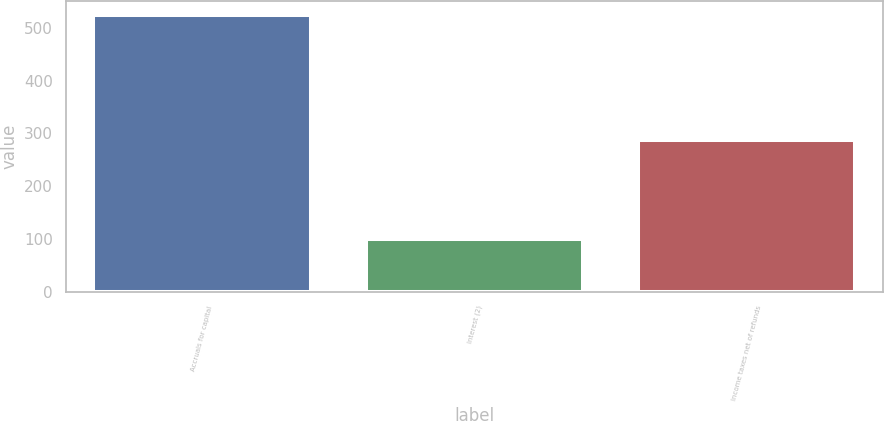<chart> <loc_0><loc_0><loc_500><loc_500><bar_chart><fcel>Accruals for capital<fcel>Interest (2)<fcel>Income taxes net of refunds<nl><fcel>525<fcel>100<fcel>287<nl></chart> 